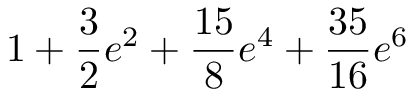Convert formula to latex. <formula><loc_0><loc_0><loc_500><loc_500>1 + \frac { 3 } { 2 } e ^ { 2 } + \frac { 1 5 } { 8 } e ^ { 4 } + \frac { 3 5 } { 1 6 } e ^ { 6 }</formula> 